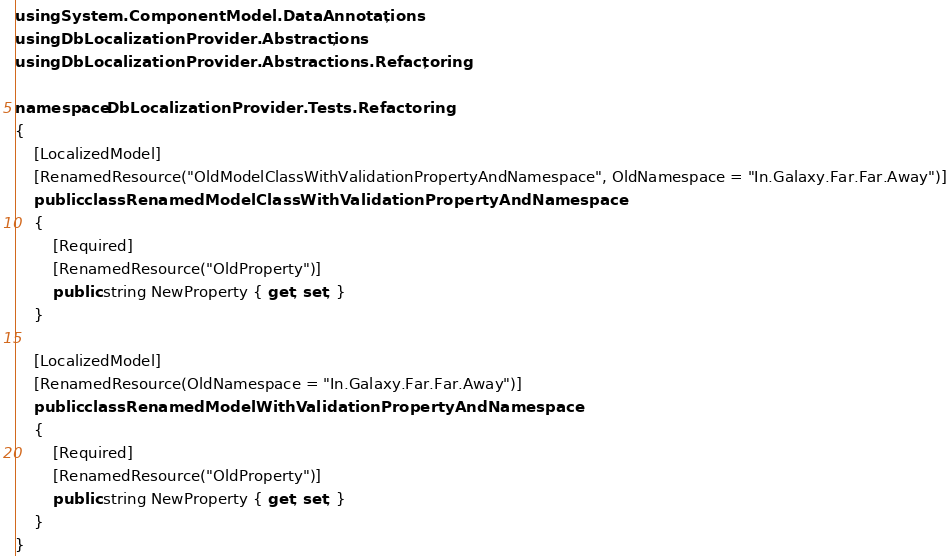<code> <loc_0><loc_0><loc_500><loc_500><_C#_>using System.ComponentModel.DataAnnotations;
using DbLocalizationProvider.Abstractions;
using DbLocalizationProvider.Abstractions.Refactoring;

namespace DbLocalizationProvider.Tests.Refactoring
{
    [LocalizedModel]
    [RenamedResource("OldModelClassWithValidationPropertyAndNamespace", OldNamespace = "In.Galaxy.Far.Far.Away")]
    public class RenamedModelClassWithValidationPropertyAndNamespace
    {
        [Required]
        [RenamedResource("OldProperty")]
        public string NewProperty { get; set; }
    }
    
    [LocalizedModel]
    [RenamedResource(OldNamespace = "In.Galaxy.Far.Far.Away")]
    public class RenamedModelWithValidationPropertyAndNamespace
    {
        [Required]
        [RenamedResource("OldProperty")]
        public string NewProperty { get; set; }
    }
}
</code> 